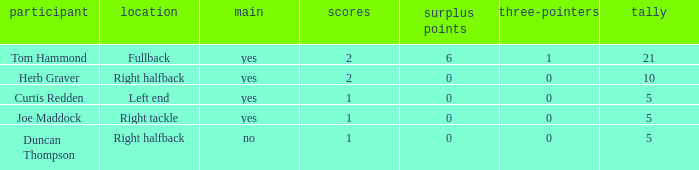Name the starter for position being left end Yes. 